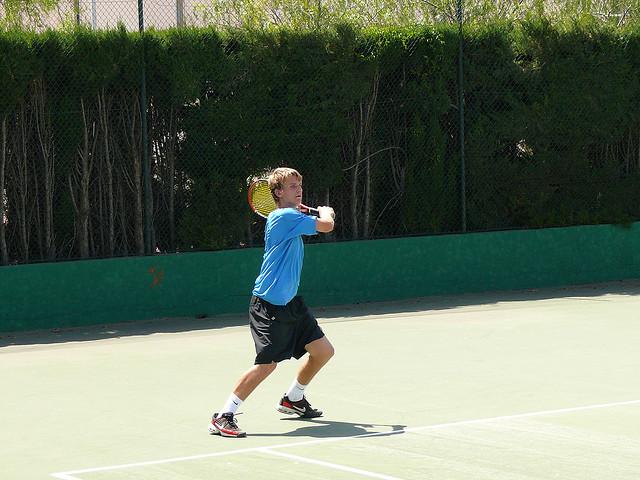Is this man happy?
Quick response, please. Yes. What game is this?
Give a very brief answer. Tennis. What is the man about to do?
Answer briefly. Hit ball. What color is his shirt?
Short answer required. Blue. 